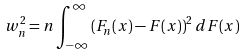<formula> <loc_0><loc_0><loc_500><loc_500>w _ { n } ^ { 2 } = n \int _ { - \infty } ^ { \infty } \left ( F _ { n } ( x ) - F ( x ) \right ) ^ { 2 } d F ( x )</formula> 